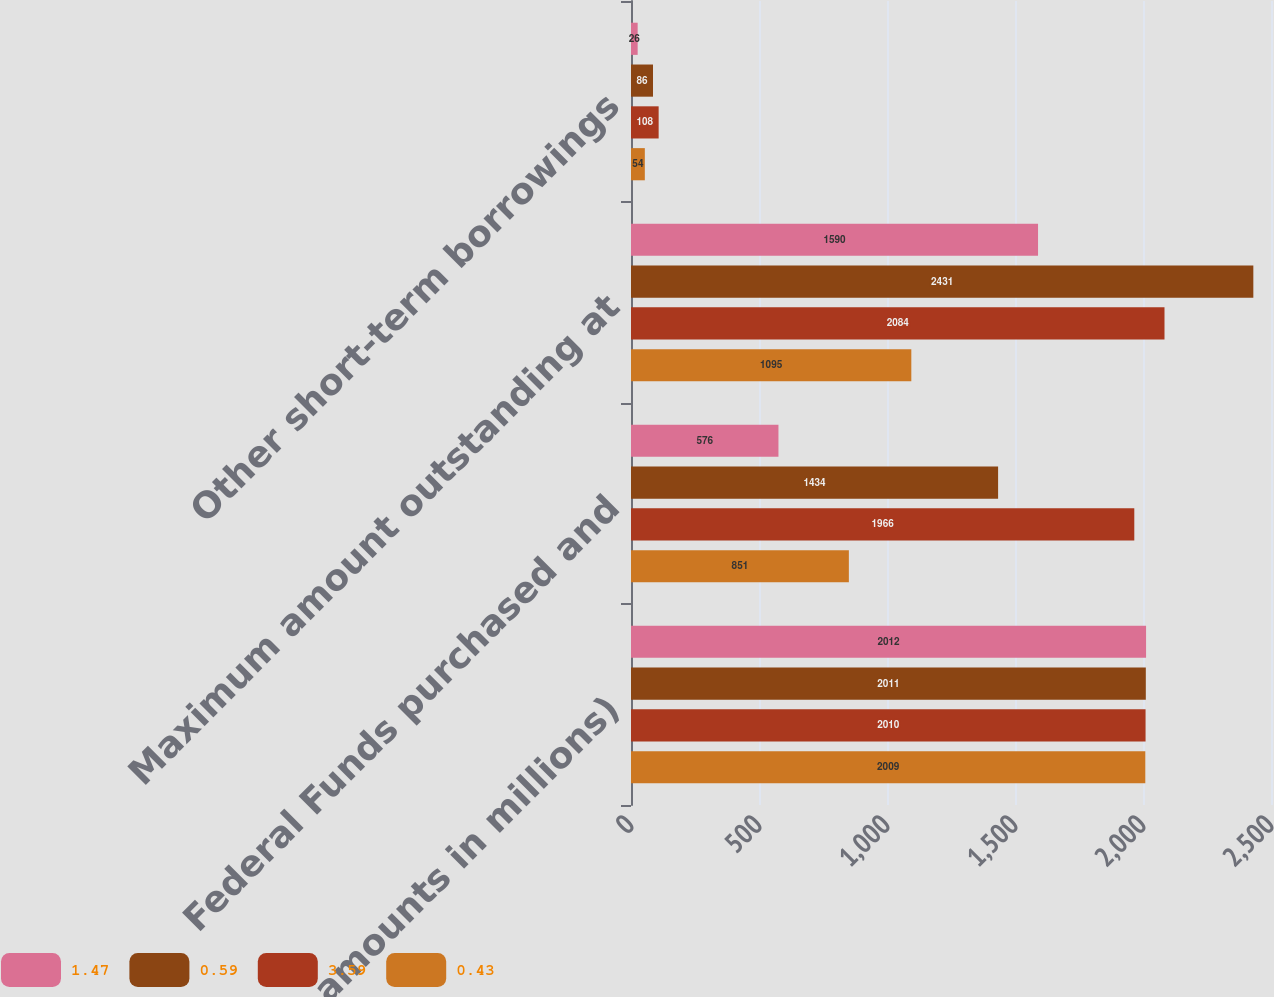<chart> <loc_0><loc_0><loc_500><loc_500><stacked_bar_chart><ecel><fcel>(dollar amounts in millions)<fcel>Federal Funds purchased and<fcel>Maximum amount outstanding at<fcel>Other short-term borrowings<nl><fcel>1.47<fcel>2012<fcel>576<fcel>1590<fcel>26<nl><fcel>0.59<fcel>2011<fcel>1434<fcel>2431<fcel>86<nl><fcel>3.59<fcel>2010<fcel>1966<fcel>2084<fcel>108<nl><fcel>0.43<fcel>2009<fcel>851<fcel>1095<fcel>54<nl></chart> 